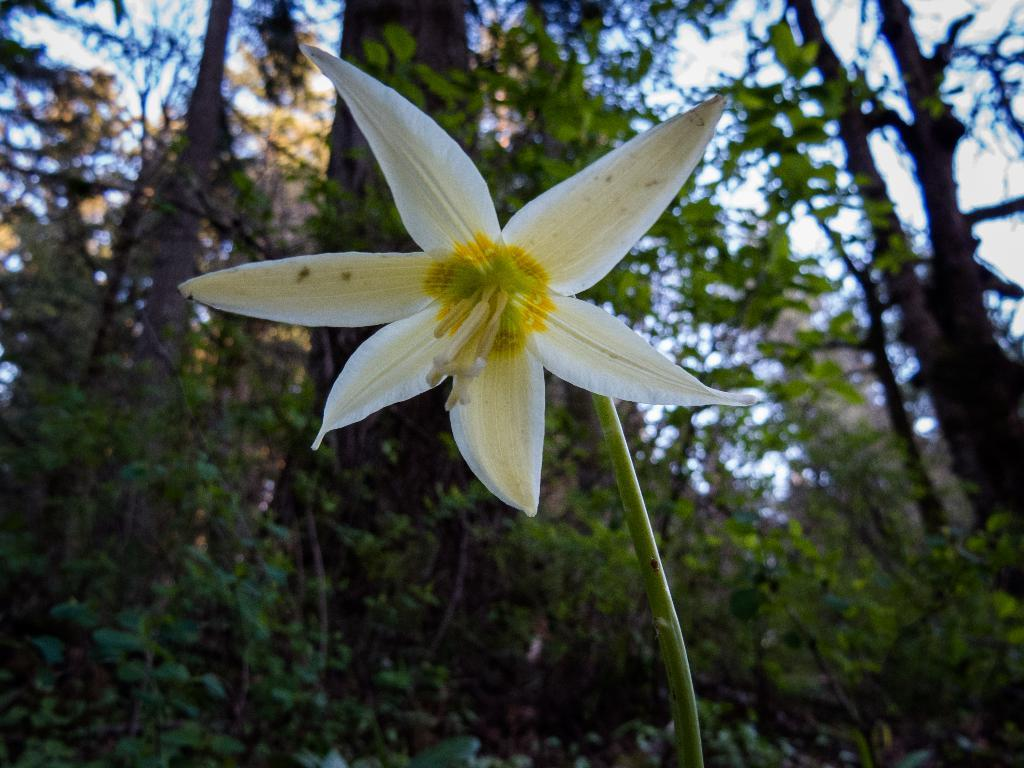What is the main subject in the center of the image? There is a flower in the center of the image. What colors can be seen on the flower? The flower has white and yellow colors. What can be seen in the background of the image? There is a sky and trees visible in the background of the image. Are there any other objects in the background of the image? Yes, there are other objects in the background of the image. What type of vest is being worn by the flower in the image? There is no vest or any clothing item visible in the image, as it features a flower. 